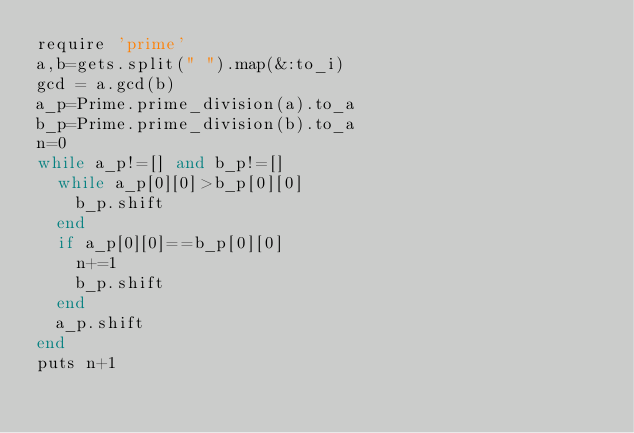Convert code to text. <code><loc_0><loc_0><loc_500><loc_500><_Ruby_>require 'prime'
a,b=gets.split(" ").map(&:to_i)
gcd = a.gcd(b)
a_p=Prime.prime_division(a).to_a
b_p=Prime.prime_division(b).to_a
n=0
while a_p!=[] and b_p!=[]
  while a_p[0][0]>b_p[0][0]
    b_p.shift
  end
  if a_p[0][0]==b_p[0][0]
    n+=1
    b_p.shift
  end
  a_p.shift
end
puts n+1</code> 